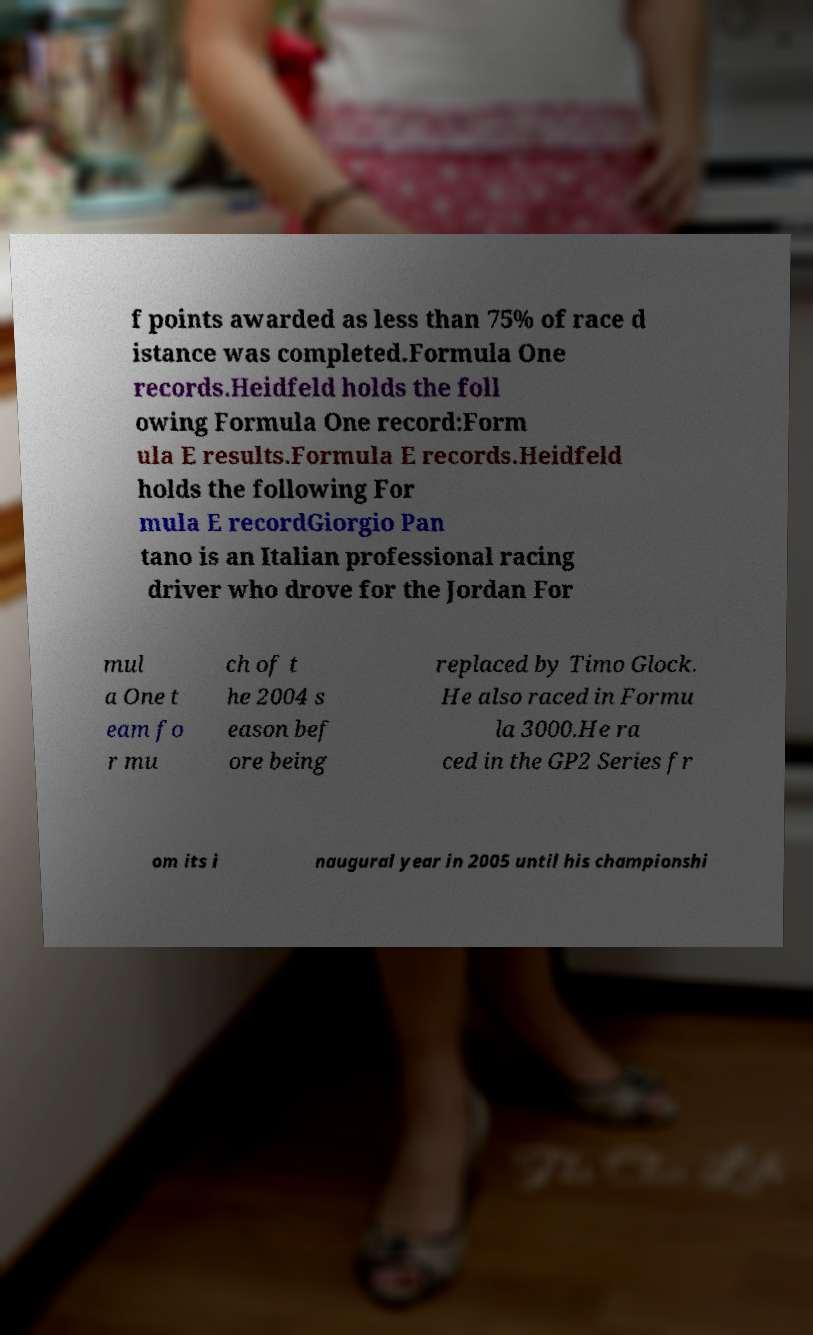There's text embedded in this image that I need extracted. Can you transcribe it verbatim? f points awarded as less than 75% of race d istance was completed.Formula One records.Heidfeld holds the foll owing Formula One record:Form ula E results.Formula E records.Heidfeld holds the following For mula E recordGiorgio Pan tano is an Italian professional racing driver who drove for the Jordan For mul a One t eam fo r mu ch of t he 2004 s eason bef ore being replaced by Timo Glock. He also raced in Formu la 3000.He ra ced in the GP2 Series fr om its i naugural year in 2005 until his championshi 